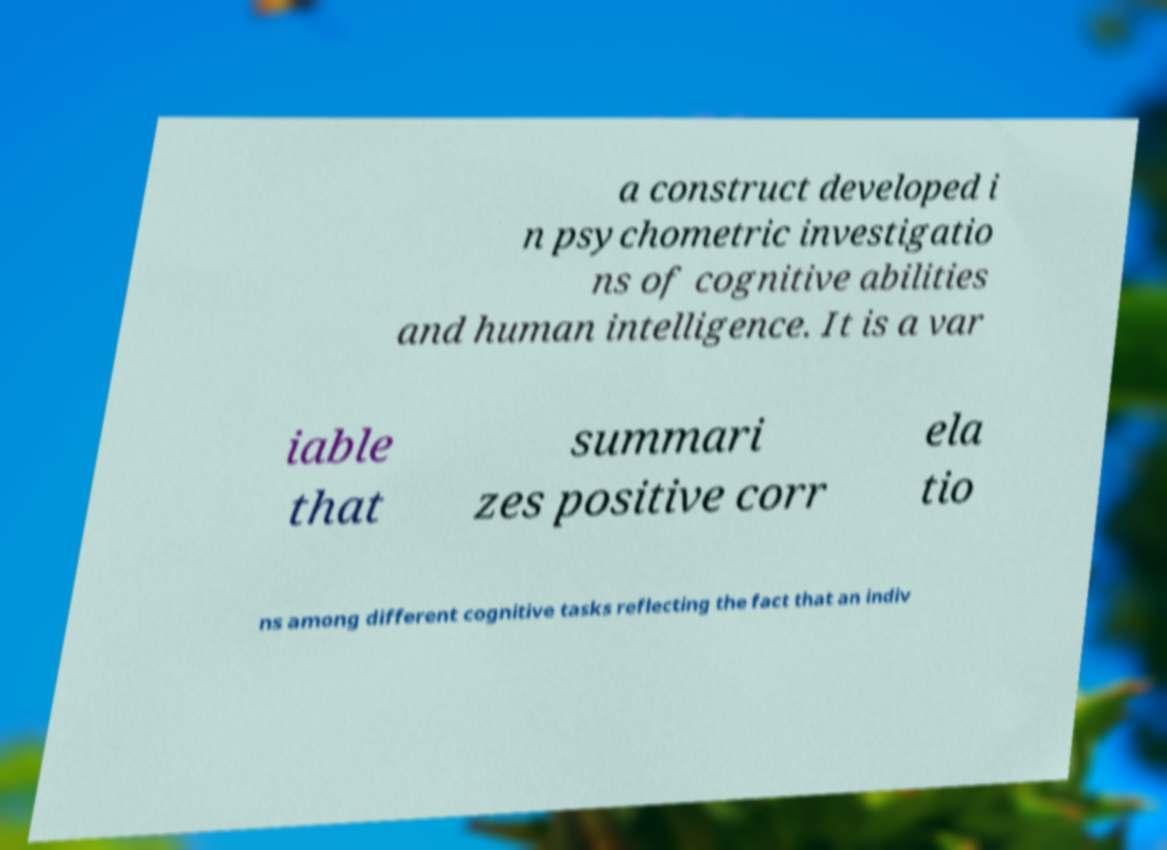Please read and relay the text visible in this image. What does it say? a construct developed i n psychometric investigatio ns of cognitive abilities and human intelligence. It is a var iable that summari zes positive corr ela tio ns among different cognitive tasks reflecting the fact that an indiv 